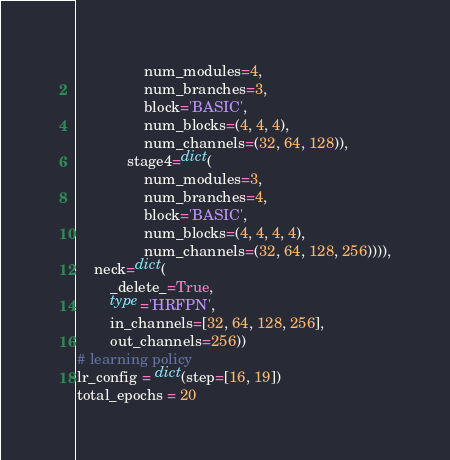<code> <loc_0><loc_0><loc_500><loc_500><_Python_>                num_modules=4,
                num_branches=3,
                block='BASIC',
                num_blocks=(4, 4, 4),
                num_channels=(32, 64, 128)),
            stage4=dict(
                num_modules=3,
                num_branches=4,
                block='BASIC',
                num_blocks=(4, 4, 4, 4),
                num_channels=(32, 64, 128, 256)))),
    neck=dict(
        _delete_=True,
        type='HRFPN',
        in_channels=[32, 64, 128, 256],
        out_channels=256))
# learning policy
lr_config = dict(step=[16, 19])
total_epochs = 20
</code> 